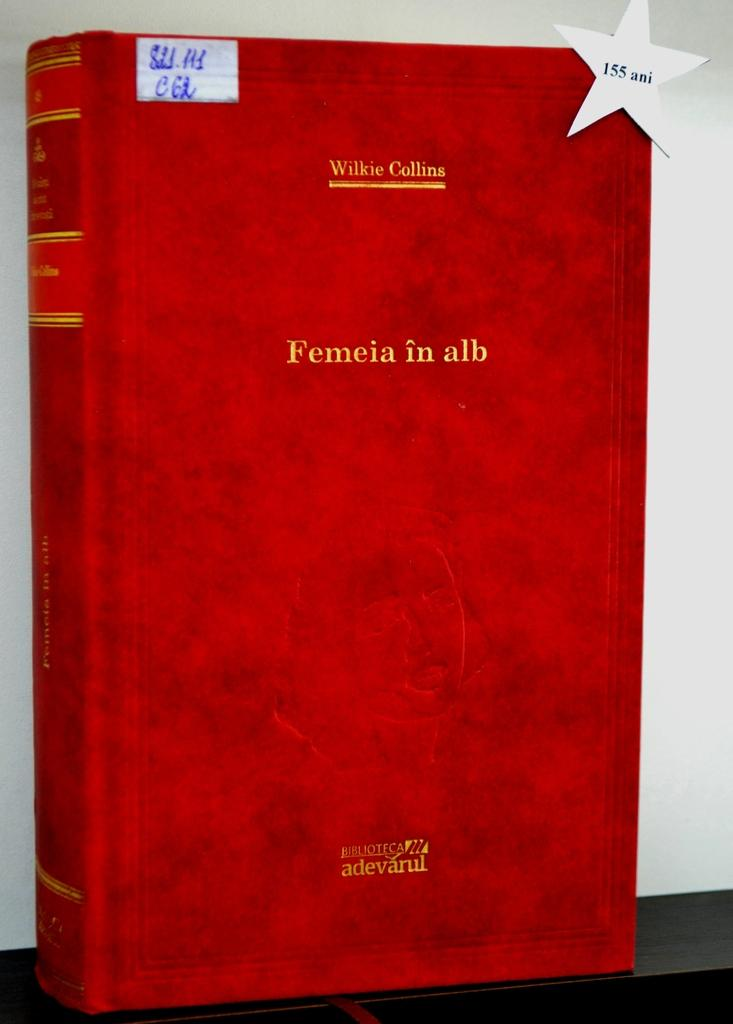<image>
Relay a brief, clear account of the picture shown. red hardback book femeia in alb by wilkie collins 